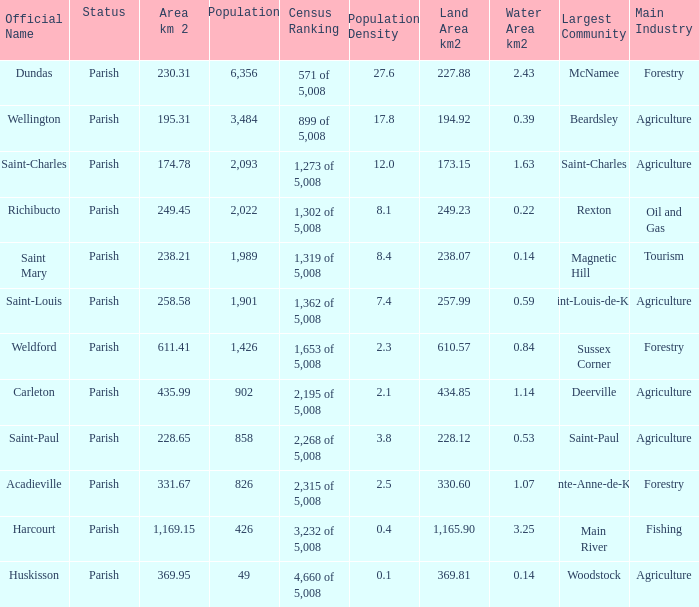For Saint-Paul parish, if it has an area of over 228.65 kilometers how many people live there? 0.0. Write the full table. {'header': ['Official Name', 'Status', 'Area km 2', 'Population', 'Census Ranking', 'Population Density', 'Land Area km2', 'Water Area km2', 'Largest Community', 'Main Industry'], 'rows': [['Dundas', 'Parish', '230.31', '6,356', '571 of 5,008', '27.6', '227.88', '2.43', 'McNamee', 'Forestry'], ['Wellington', 'Parish', '195.31', '3,484', '899 of 5,008', '17.8', '194.92', '0.39', 'Beardsley', 'Agriculture'], ['Saint-Charles', 'Parish', '174.78', '2,093', '1,273 of 5,008', '12.0', '173.15', '1.63', 'Saint-Charles', 'Agriculture'], ['Richibucto', 'Parish', '249.45', '2,022', '1,302 of 5,008', '8.1', '249.23', '0.22', 'Rexton', 'Oil and Gas'], ['Saint Mary', 'Parish', '238.21', '1,989', '1,319 of 5,008', '8.4', '238.07', '0.14', 'Magnetic Hill', 'Tourism'], ['Saint-Louis', 'Parish', '258.58', '1,901', '1,362 of 5,008', '7.4', '257.99', '0.59', 'Saint-Louis-de-Kent', 'Agriculture'], ['Weldford', 'Parish', '611.41', '1,426', '1,653 of 5,008', '2.3', '610.57', '0.84', 'Sussex Corner', 'Forestry'], ['Carleton', 'Parish', '435.99', '902', '2,195 of 5,008', '2.1', '434.85', '1.14', 'Deerville', 'Agriculture'], ['Saint-Paul', 'Parish', '228.65', '858', '2,268 of 5,008', '3.8', '228.12', '0.53', 'Saint-Paul', 'Agriculture'], ['Acadieville', 'Parish', '331.67', '826', '2,315 of 5,008', '2.5', '330.60', '1.07', 'Sainte-Anne-de-Kent', 'Forestry'], ['Harcourt', 'Parish', '1,169.15', '426', '3,232 of 5,008', '0.4', '1,165.90', '3.25', 'Main River', 'Fishing'], ['Huskisson', 'Parish', '369.95', '49', '4,660 of 5,008', '0.1', '369.81', '0.14', 'Woodstock', 'Agriculture']]} 